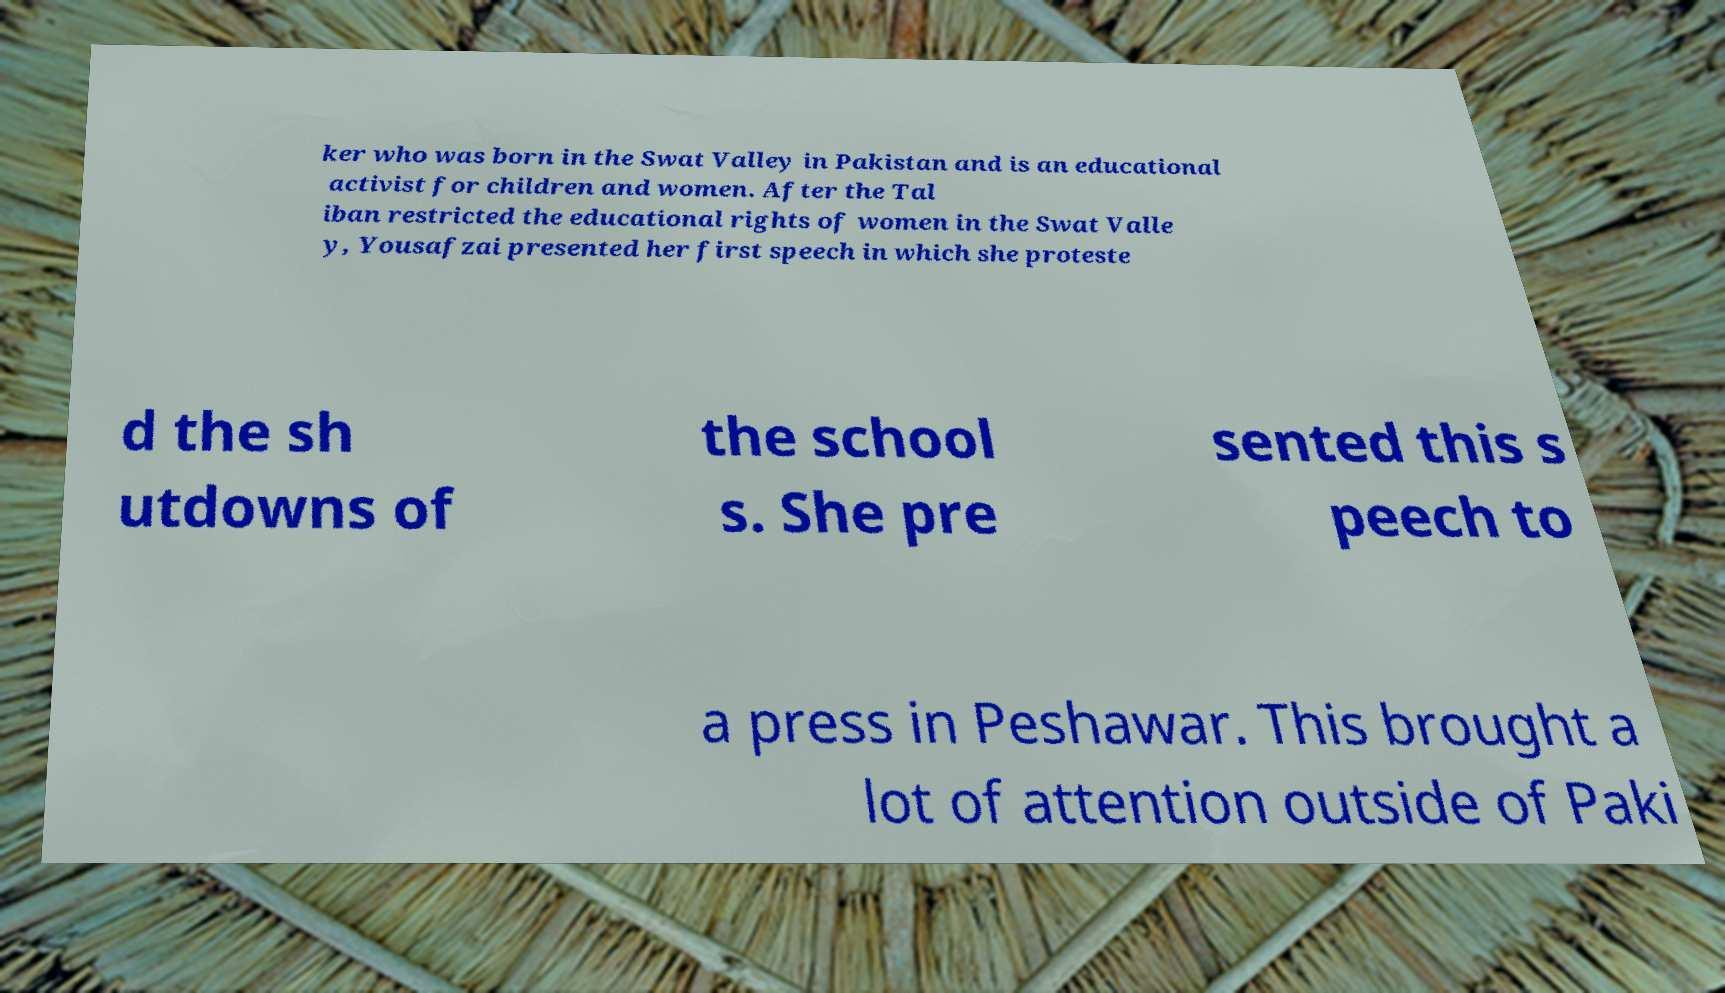Could you extract and type out the text from this image? ker who was born in the Swat Valley in Pakistan and is an educational activist for children and women. After the Tal iban restricted the educational rights of women in the Swat Valle y, Yousafzai presented her first speech in which she proteste d the sh utdowns of the school s. She pre sented this s peech to a press in Peshawar. This brought a lot of attention outside of Paki 